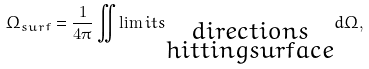Convert formula to latex. <formula><loc_0><loc_0><loc_500><loc_500>\Omega _ { s u r f } = \frac { 1 } { 4 \pi } \iint \lim i t s _ { \substack { d i r e c t i o n s \\ h i t t i n g s u r f a c e } } d \Omega ,</formula> 